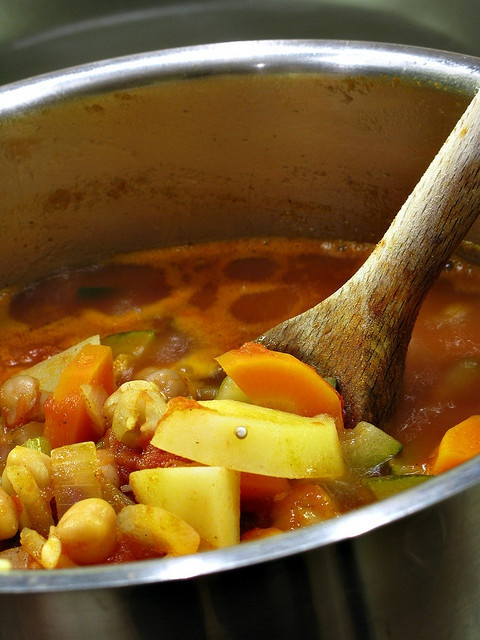Describe the objects in this image and their specific colors. I can see bowl in maroon, black, brown, and gray tones, spoon in gray, maroon, black, and olive tones, carrot in gray, red, orange, and brown tones, carrot in gray, brown, red, and maroon tones, and carrot in gray, orange, red, and brown tones in this image. 